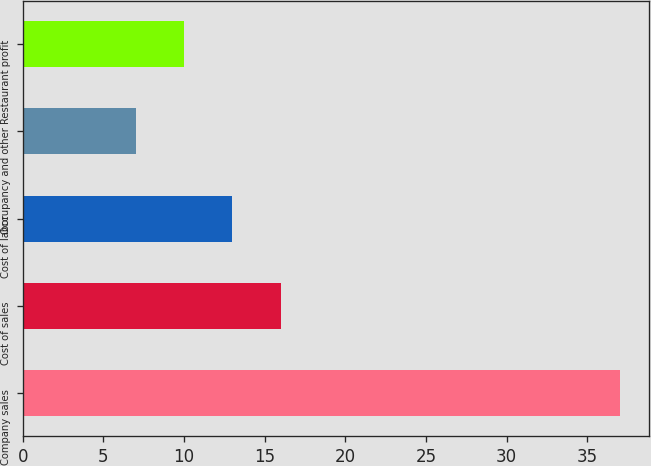Convert chart to OTSL. <chart><loc_0><loc_0><loc_500><loc_500><bar_chart><fcel>Company sales<fcel>Cost of sales<fcel>Cost of labor<fcel>Occupancy and other<fcel>Restaurant profit<nl><fcel>37<fcel>16<fcel>13<fcel>7<fcel>10<nl></chart> 